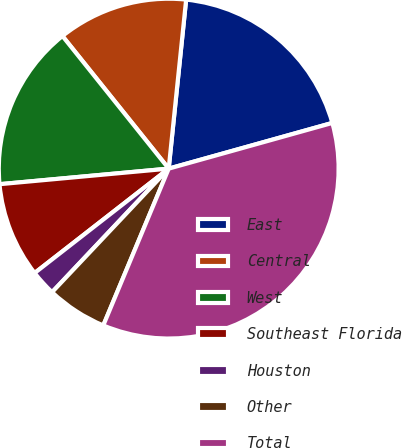<chart> <loc_0><loc_0><loc_500><loc_500><pie_chart><fcel>East<fcel>Central<fcel>West<fcel>Southeast Florida<fcel>Houston<fcel>Other<fcel>Total<nl><fcel>19.03%<fcel>12.39%<fcel>15.71%<fcel>9.07%<fcel>2.43%<fcel>5.75%<fcel>35.63%<nl></chart> 